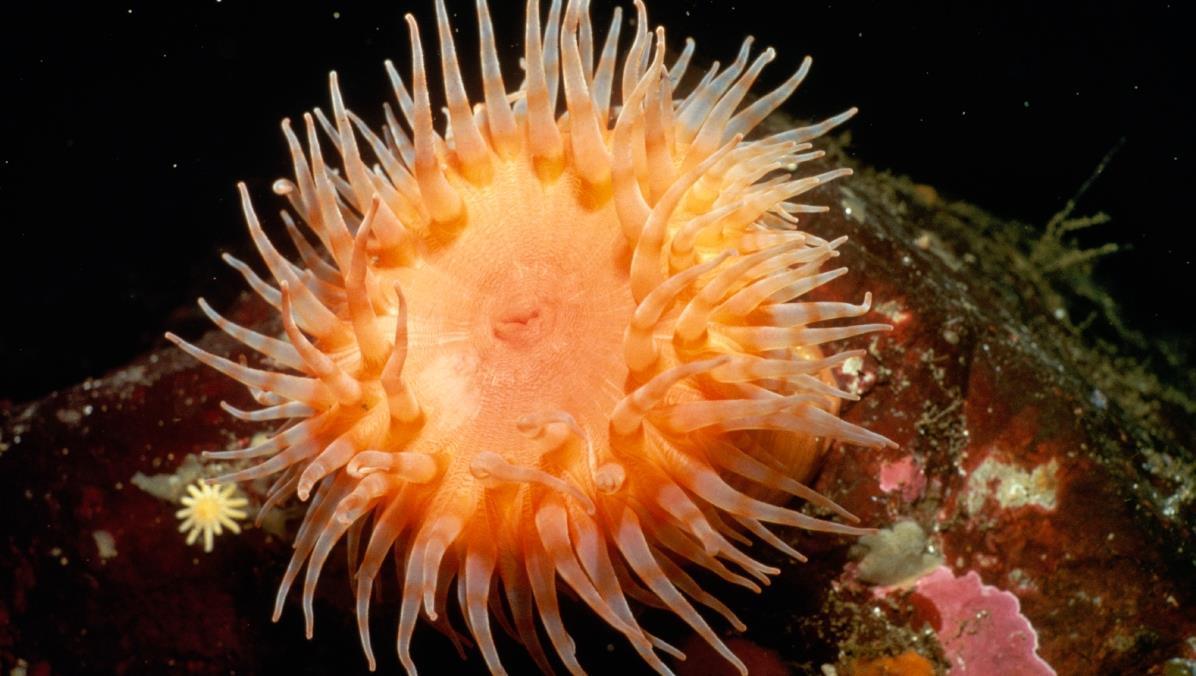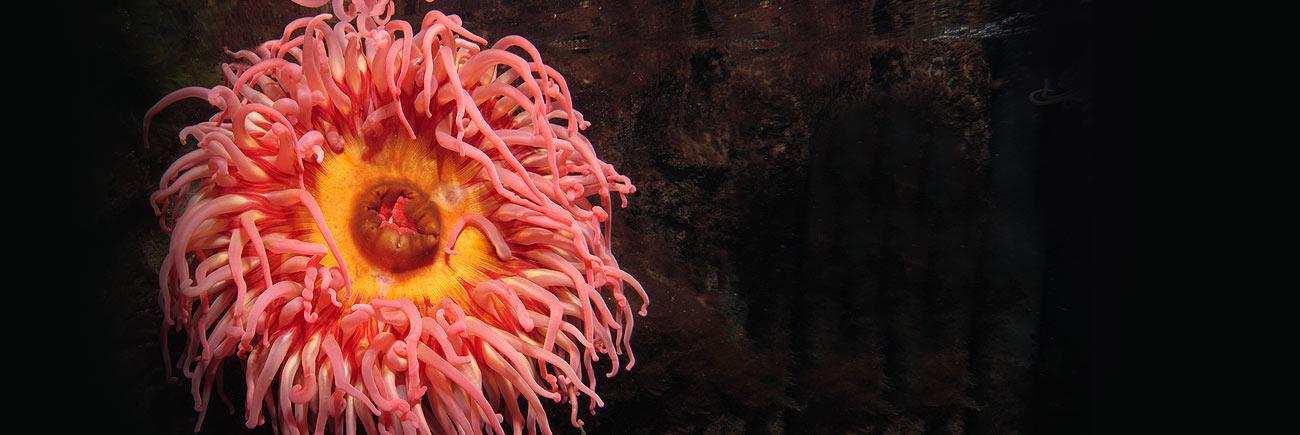The first image is the image on the left, the second image is the image on the right. Assess this claim about the two images: "There are at least two creatures in the image on the left.". Correct or not? Answer yes or no. Yes. 